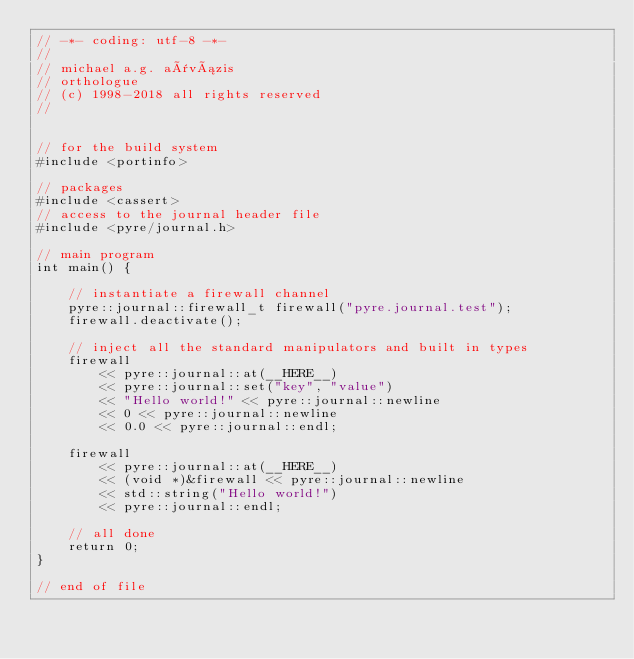Convert code to text. <code><loc_0><loc_0><loc_500><loc_500><_C++_>// -*- coding: utf-8 -*-
//
// michael a.g. aïvázis
// orthologue
// (c) 1998-2018 all rights reserved
//


// for the build system
#include <portinfo>

// packages
#include <cassert>
// access to the journal header file
#include <pyre/journal.h>

// main program
int main() {

    // instantiate a firewall channel
    pyre::journal::firewall_t firewall("pyre.journal.test");
    firewall.deactivate();

    // inject all the standard manipulators and built in types
    firewall
        << pyre::journal::at(__HERE__)
        << pyre::journal::set("key", "value")
        << "Hello world!" << pyre::journal::newline
        << 0 << pyre::journal::newline
        << 0.0 << pyre::journal::endl;

    firewall
        << pyre::journal::at(__HERE__)
        << (void *)&firewall << pyre::journal::newline
        << std::string("Hello world!")
        << pyre::journal::endl;

    // all done
    return 0;
}

// end of file
</code> 